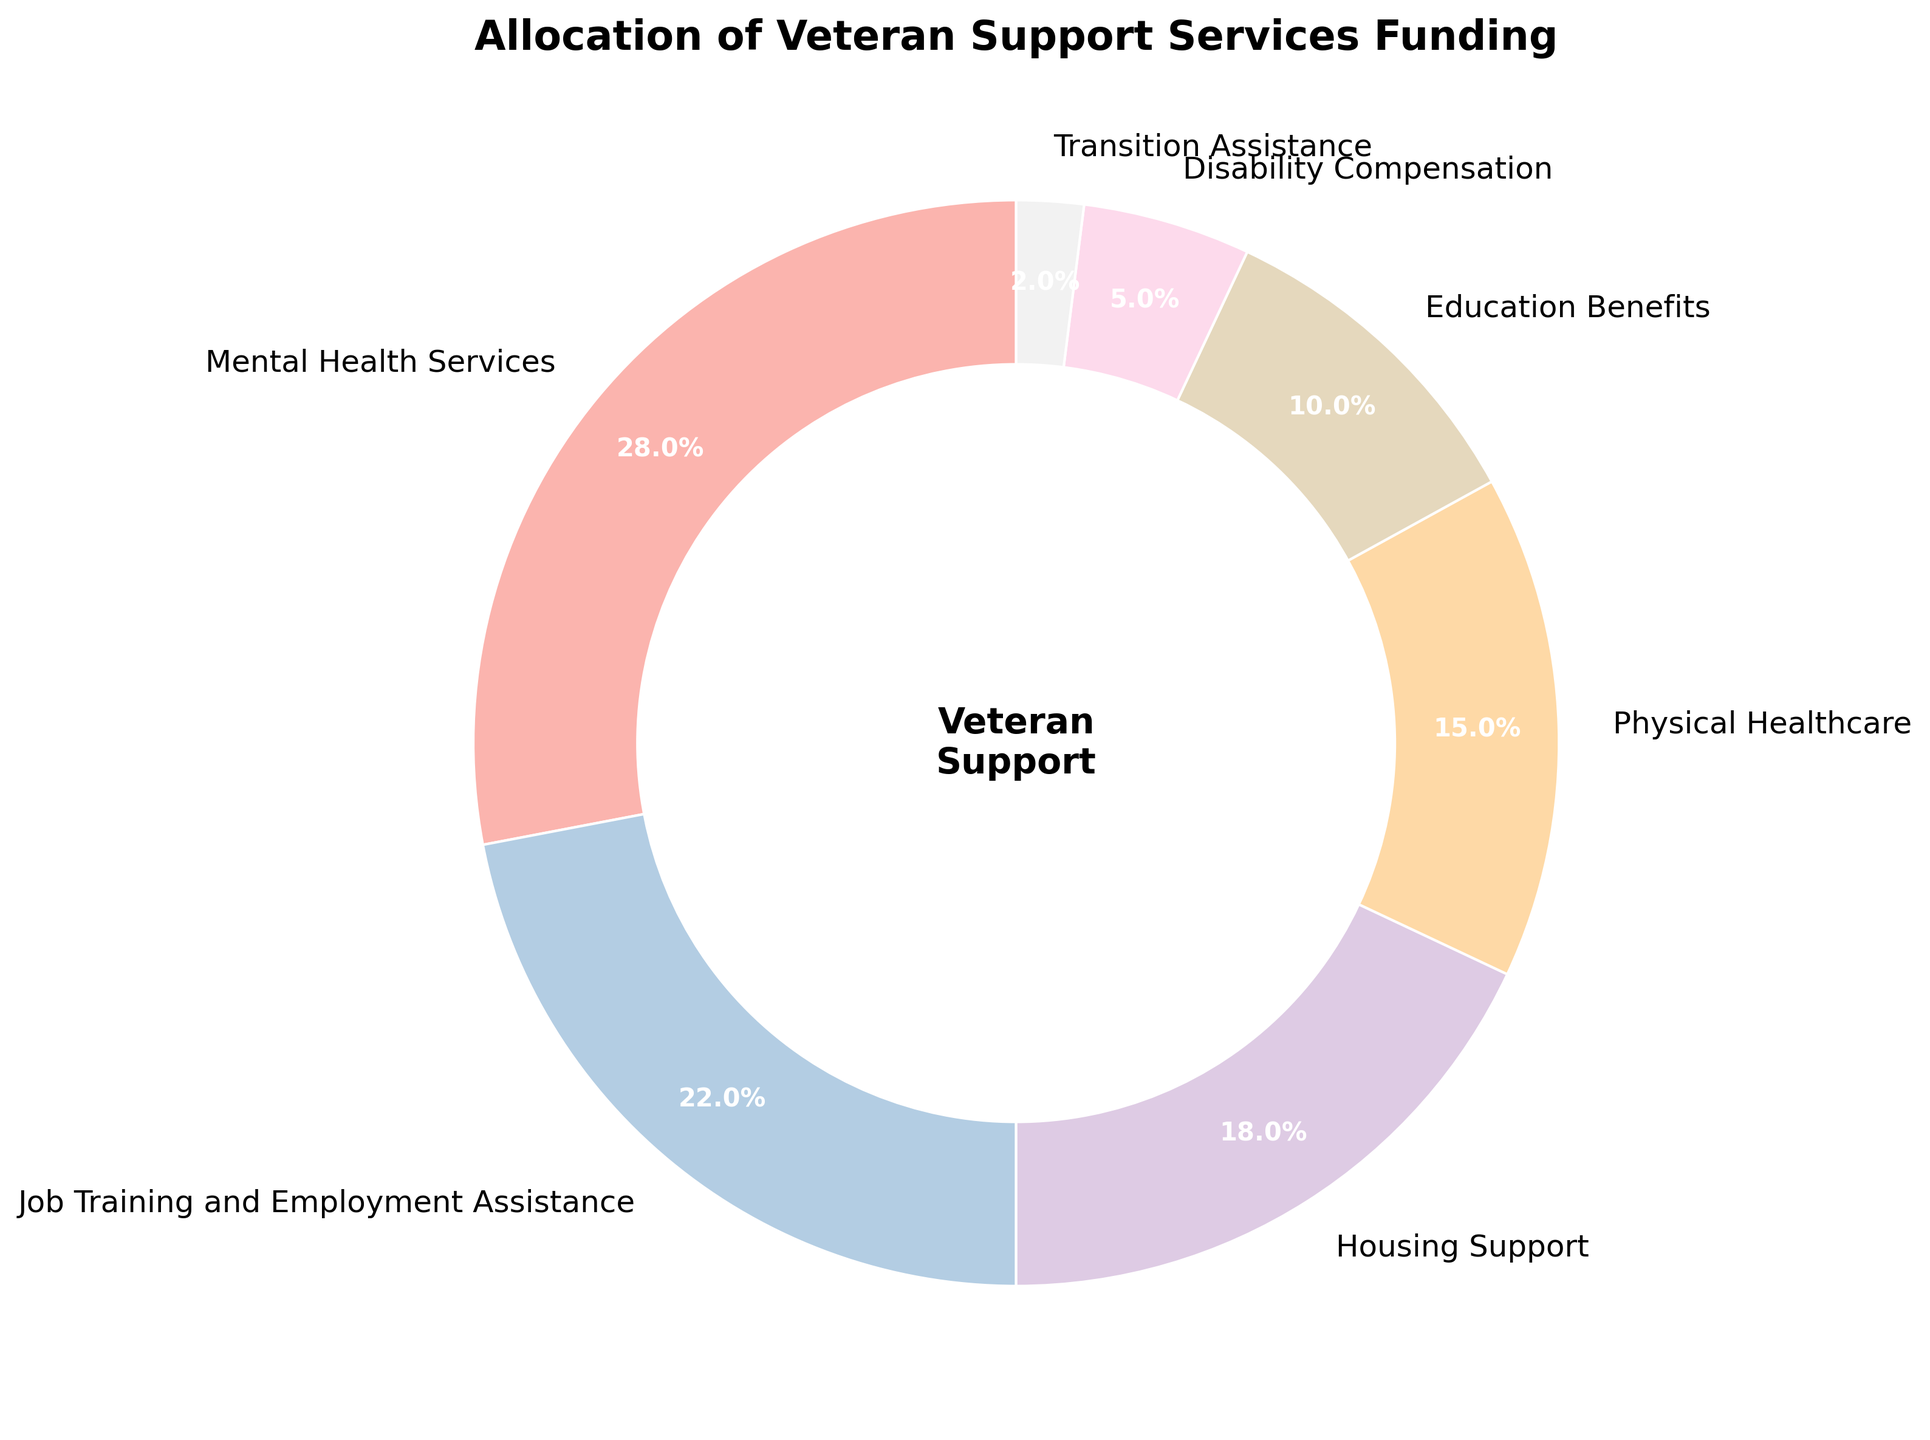What percentage of the funding is allocated to Mental Health Services and Physical Healthcare combined? First, identify the percentage allocated to Mental Health Services (28%) and Physical Healthcare (15%). Sum these two percentages: 28% + 15% = 43%.
Answer: 43% Which category receives more funding: Housing Support or Education Benefits? Identify the percentages for Housing Support (18%) and Education Benefits (10%). Compare these two values: 18% is greater than 10%.
Answer: Housing Support How much more funding (in percentage points) is allocated to Job Training and Employment Assistance compared to Disability Compensation? Identify the percentages for Job Training and Employment Assistance (22%) and Disability Compensation (5%). Subtract the smaller percentage from the larger one: 22% - 5% = 17%.
Answer: 17% What is the percentage difference between the highest and the lowest funded categories? Identify the highest funded category (Mental Health Services at 28%) and the lowest funded category (Transition Assistance at 2%). Subtract the smallest percentage from the largest one: 28% - 2% = 26%.
Answer: 26% Considering Mental Health Services, Job Training and Employment Assistance, and Housing Support, what is their average funding percentage? Identify the percentages for these categories: Mental Health Services (28%), Job Training and Employment Assistance (22%), and Housing Support (18%). Sum these percentages: 28% + 22% + 18% = 68%. Divide by the number of categories (3): 68% / 3 ≈ 22.67%.
Answer: 22.67% Which slice on the pie chart is represented with the most percentage? By visually checking the size of the slices in the pie chart, identify the largest slice, which corresponds to Mental Health Services at 28%.
Answer: Mental Health Services How much more funding (in percentage points) does Physical Healthcare receive compared to Transition Assistance and Disability Compensation combined? Identify the percentages for Physical Healthcare (15%), Transition Assistance (2%), and Disability Compensation (5%). Sum the percentages for Transition Assistance and Disability Compensation: 2% + 5% = 7%. Subtract this sum from the percentage for Physical Healthcare: 15% - 7% = 8%.
Answer: 8% Which funding allocation category is second highest? By comparing the percentages, the second highest allocation is for Job Training and Employment Assistance at 22%.
Answer: Job Training and Employment Assistance If Education Benefits received the same percentage as Housing Support, what would the total percentage increase be? Identify current percentages for Education Benefits (10%) and Housing Support (18%). The difference is 18% - 10% = 8%, so the increase would be 8 percentage points.
Answer: 8% Which category is represented in the color just next to the Transition Assistance slice? Visually identify the color of the slice next to the Transition Assistance category. The next slice is Disability Compensation.
Answer: Disability Compensation 